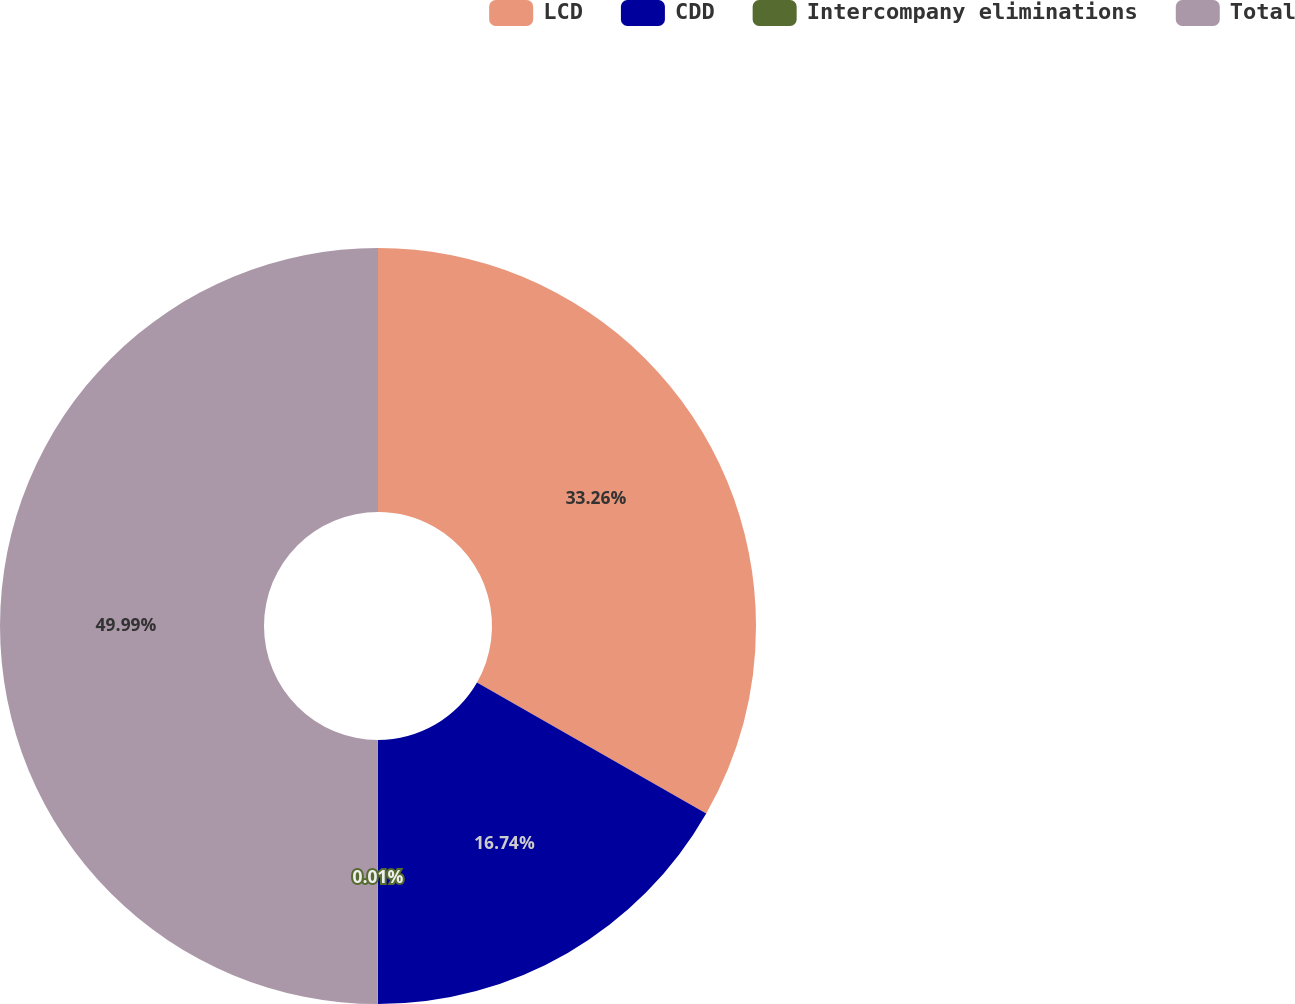Convert chart. <chart><loc_0><loc_0><loc_500><loc_500><pie_chart><fcel>LCD<fcel>CDD<fcel>Intercompany eliminations<fcel>Total<nl><fcel>33.26%<fcel>16.74%<fcel>0.01%<fcel>49.99%<nl></chart> 